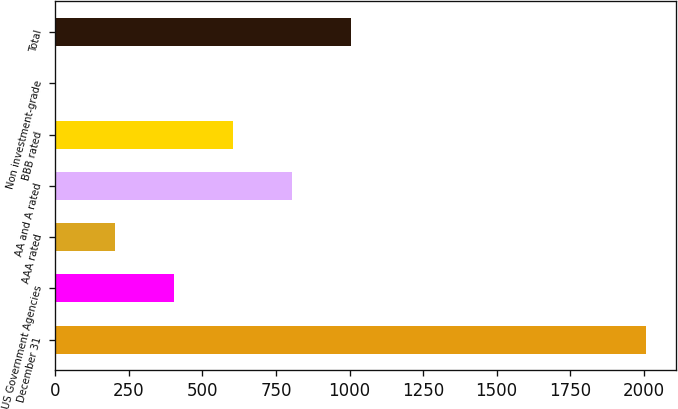<chart> <loc_0><loc_0><loc_500><loc_500><bar_chart><fcel>December 31<fcel>US Government Agencies<fcel>AAA rated<fcel>AA and A rated<fcel>BBB rated<fcel>Non investment-grade<fcel>Total<nl><fcel>2008<fcel>402.4<fcel>201.7<fcel>803.8<fcel>603.1<fcel>1<fcel>1004.5<nl></chart> 